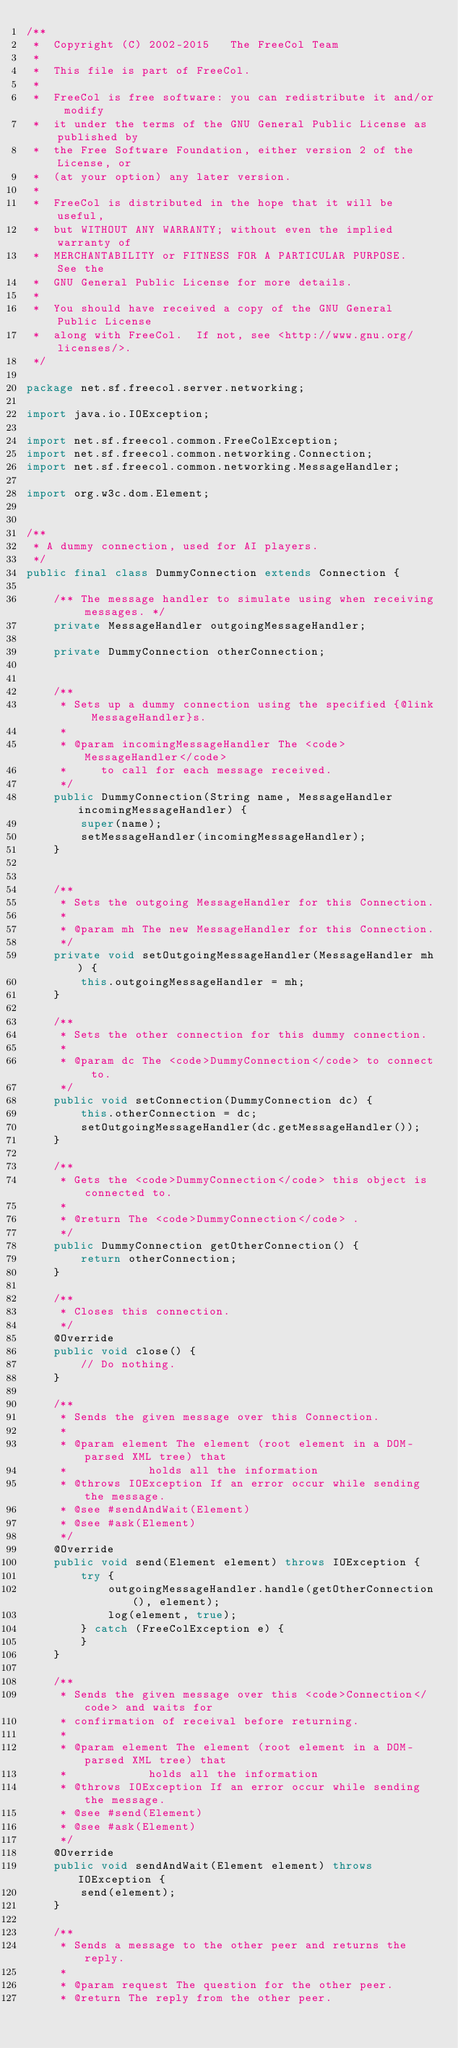<code> <loc_0><loc_0><loc_500><loc_500><_Java_>/**
 *  Copyright (C) 2002-2015   The FreeCol Team
 *
 *  This file is part of FreeCol.
 *
 *  FreeCol is free software: you can redistribute it and/or modify
 *  it under the terms of the GNU General Public License as published by
 *  the Free Software Foundation, either version 2 of the License, or
 *  (at your option) any later version.
 *
 *  FreeCol is distributed in the hope that it will be useful,
 *  but WITHOUT ANY WARRANTY; without even the implied warranty of
 *  MERCHANTABILITY or FITNESS FOR A PARTICULAR PURPOSE.  See the
 *  GNU General Public License for more details.
 *
 *  You should have received a copy of the GNU General Public License
 *  along with FreeCol.  If not, see <http://www.gnu.org/licenses/>.
 */

package net.sf.freecol.server.networking;

import java.io.IOException;

import net.sf.freecol.common.FreeColException;
import net.sf.freecol.common.networking.Connection;
import net.sf.freecol.common.networking.MessageHandler;

import org.w3c.dom.Element;


/**
 * A dummy connection, used for AI players.
 */
public final class DummyConnection extends Connection {

    /** The message handler to simulate using when receiving messages. */
    private MessageHandler outgoingMessageHandler;

    private DummyConnection otherConnection;


    /**
     * Sets up a dummy connection using the specified {@link MessageHandler}s.
     *
     * @param incomingMessageHandler The <code>MessageHandler</code>
     *     to call for each message received.
     */
    public DummyConnection(String name, MessageHandler incomingMessageHandler) {
        super(name);
        setMessageHandler(incomingMessageHandler);
    }


    /**
     * Sets the outgoing MessageHandler for this Connection.
     *
     * @param mh The new MessageHandler for this Connection.
     */
    private void setOutgoingMessageHandler(MessageHandler mh) {
        this.outgoingMessageHandler = mh;
    }

    /**
     * Sets the other connection for this dummy connection.
     *
     * @param dc The <code>DummyConnection</code> to connect to.
     */
    public void setConnection(DummyConnection dc) {
        this.otherConnection = dc;
        setOutgoingMessageHandler(dc.getMessageHandler());
    }

    /**
     * Gets the <code>DummyConnection</code> this object is connected to.
     *
     * @return The <code>DummyConnection</code> .
     */
    public DummyConnection getOtherConnection() {
        return otherConnection;
    }

    /**
     * Closes this connection.
     */
    @Override
    public void close() {
        // Do nothing.
    }

    /**
     * Sends the given message over this Connection.
     *
     * @param element The element (root element in a DOM-parsed XML tree) that
     *            holds all the information
     * @throws IOException If an error occur while sending the message.
     * @see #sendAndWait(Element)
     * @see #ask(Element)
     */
    @Override
    public void send(Element element) throws IOException {
        try {
            outgoingMessageHandler.handle(getOtherConnection(), element);
            log(element, true);
        } catch (FreeColException e) {
        }
    }

    /**
     * Sends the given message over this <code>Connection</code> and waits for
     * confirmation of receival before returning.
     *
     * @param element The element (root element in a DOM-parsed XML tree) that
     *            holds all the information
     * @throws IOException If an error occur while sending the message.
     * @see #send(Element)
     * @see #ask(Element)
     */
    @Override
    public void sendAndWait(Element element) throws IOException {
        send(element);
    }

    /**
     * Sends a message to the other peer and returns the reply.
     *
     * @param request The question for the other peer.
     * @return The reply from the other peer.</code> 